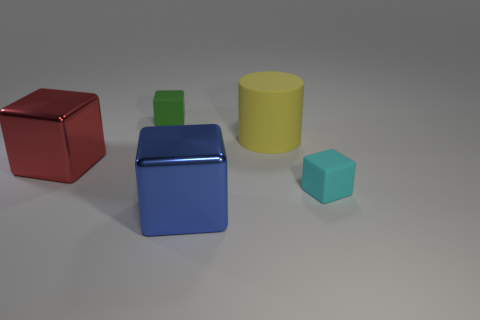Subtract all small green matte blocks. How many blocks are left? 3 Subtract 1 cylinders. How many cylinders are left? 0 Add 2 large yellow matte cylinders. How many objects exist? 7 Subtract all red blocks. How many blocks are left? 3 Subtract all blocks. How many objects are left? 1 Add 5 small brown rubber things. How many small brown rubber things exist? 5 Subtract 0 yellow balls. How many objects are left? 5 Subtract all blue cylinders. Subtract all brown balls. How many cylinders are left? 1 Subtract all blue cylinders. How many brown blocks are left? 0 Subtract all cylinders. Subtract all large gray rubber cylinders. How many objects are left? 4 